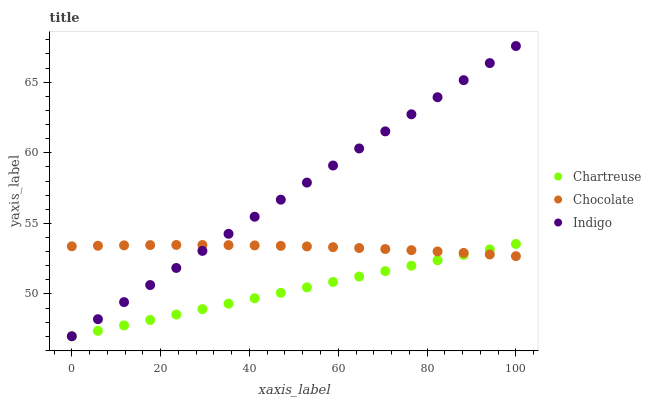Does Chartreuse have the minimum area under the curve?
Answer yes or no. Yes. Does Indigo have the maximum area under the curve?
Answer yes or no. Yes. Does Chocolate have the minimum area under the curve?
Answer yes or no. No. Does Chocolate have the maximum area under the curve?
Answer yes or no. No. Is Indigo the smoothest?
Answer yes or no. Yes. Is Chocolate the roughest?
Answer yes or no. Yes. Is Chocolate the smoothest?
Answer yes or no. No. Is Indigo the roughest?
Answer yes or no. No. Does Chartreuse have the lowest value?
Answer yes or no. Yes. Does Chocolate have the lowest value?
Answer yes or no. No. Does Indigo have the highest value?
Answer yes or no. Yes. Does Chocolate have the highest value?
Answer yes or no. No. Does Chartreuse intersect Chocolate?
Answer yes or no. Yes. Is Chartreuse less than Chocolate?
Answer yes or no. No. Is Chartreuse greater than Chocolate?
Answer yes or no. No. 